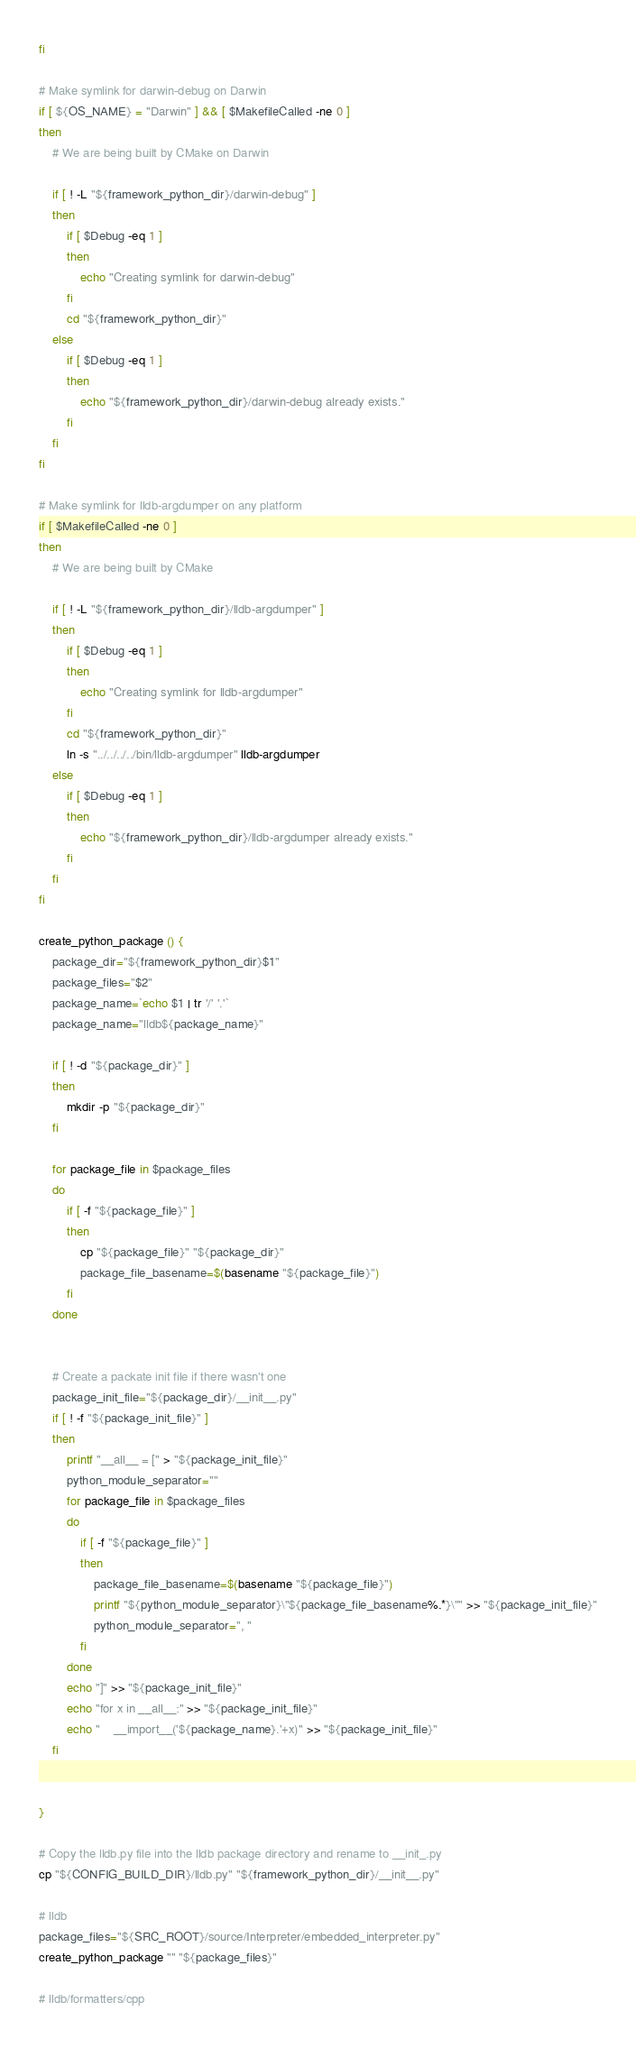Convert code to text. <code><loc_0><loc_0><loc_500><loc_500><_Bash_>fi

# Make symlink for darwin-debug on Darwin
if [ ${OS_NAME} = "Darwin" ] && [ $MakefileCalled -ne 0 ]
then
    # We are being built by CMake on Darwin

    if [ ! -L "${framework_python_dir}/darwin-debug" ]
    then
        if [ $Debug -eq 1 ]
        then
            echo "Creating symlink for darwin-debug"
        fi
        cd "${framework_python_dir}"
    else
        if [ $Debug -eq 1 ]
        then
            echo "${framework_python_dir}/darwin-debug already exists."
        fi
    fi
fi

# Make symlink for lldb-argdumper on any platform
if [ $MakefileCalled -ne 0 ]
then
    # We are being built by CMake

    if [ ! -L "${framework_python_dir}/lldb-argdumper" ]
    then
        if [ $Debug -eq 1 ]
        then
            echo "Creating symlink for lldb-argdumper"
        fi
        cd "${framework_python_dir}"
        ln -s "../../../../bin/lldb-argdumper" lldb-argdumper
    else
        if [ $Debug -eq 1 ]
        then
            echo "${framework_python_dir}/lldb-argdumper already exists."
        fi
    fi
fi

create_python_package () {
    package_dir="${framework_python_dir}$1"
    package_files="$2"
    package_name=`echo $1 | tr '/' '.'`
    package_name="lldb${package_name}"

    if [ ! -d "${package_dir}" ]
    then
        mkdir -p "${package_dir}"
    fi

    for package_file in $package_files
    do
        if [ -f "${package_file}" ]
        then
            cp "${package_file}" "${package_dir}"
            package_file_basename=$(basename "${package_file}")
        fi
    done


    # Create a packate init file if there wasn't one
    package_init_file="${package_dir}/__init__.py"
    if [ ! -f "${package_init_file}" ]
    then
        printf "__all__ = [" > "${package_init_file}"
        python_module_separator=""
        for package_file in $package_files
        do
            if [ -f "${package_file}" ]
            then
                package_file_basename=$(basename "${package_file}")
                printf "${python_module_separator}\"${package_file_basename%.*}\"" >> "${package_init_file}"
                python_module_separator=", "
            fi
        done
        echo "]" >> "${package_init_file}"
        echo "for x in __all__:" >> "${package_init_file}"
        echo "    __import__('${package_name}.'+x)" >> "${package_init_file}"
    fi


}

# Copy the lldb.py file into the lldb package directory and rename to __init_.py
cp "${CONFIG_BUILD_DIR}/lldb.py" "${framework_python_dir}/__init__.py"

# lldb
package_files="${SRC_ROOT}/source/Interpreter/embedded_interpreter.py"
create_python_package "" "${package_files}"

# lldb/formatters/cpp</code> 